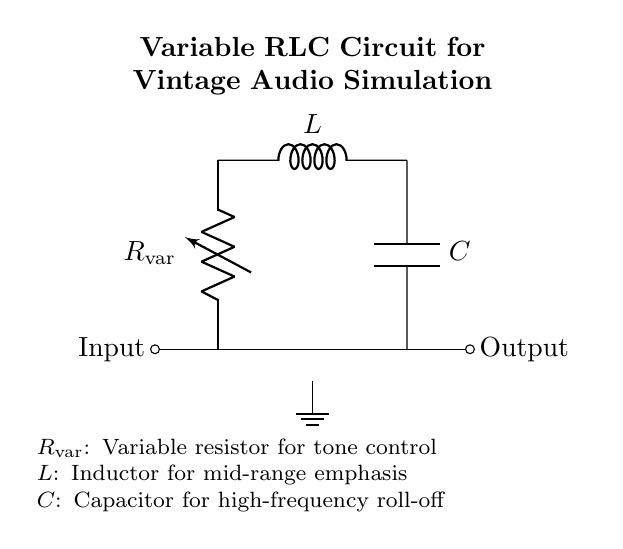What component is used for tone control? The variable resistor, labeled as R var, in the circuit is dedicated to adjusting the tone, allowing modification of audio characteristics.
Answer: Variable resistor What is the function of the inductor in this circuit? The inductor, labeled as L, is primarily used to emphasize mid-range frequencies in the audio signal by opposing changes in current.
Answer: Mid-range emphasis Which component is responsible for high-frequency roll-off? The capacitor, labeled as C, is designed to block low frequencies and allow high frequencies to pass through, effectively rolling off high frequencies.
Answer: Capacitor How many components are present in this circuit? There are three components: one variable resistor, one inductor, and one capacitor, which makes a total of three components.
Answer: Three What happens when the resistance is increased? Increasing the resistance in the variable resistor R var will reduce the current flowing through the circuit and subsequently affect the overall output tone, typically resulting in a darker sound.
Answer: Darker sound What is the circuit type used in this diagram? This circuit is classified as a variable RLC circuit because it consists of a resistor, inductor, and capacitor, which can be adjusted to alter the audio characteristics.
Answer: Variable RLC circuit 